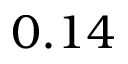Convert formula to latex. <formula><loc_0><loc_0><loc_500><loc_500>0 . 1 4</formula> 